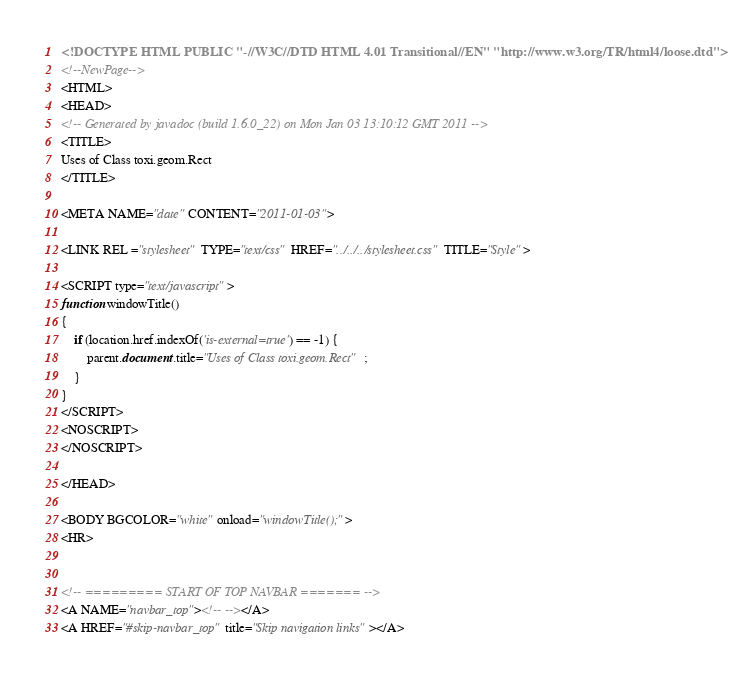<code> <loc_0><loc_0><loc_500><loc_500><_HTML_><!DOCTYPE HTML PUBLIC "-//W3C//DTD HTML 4.01 Transitional//EN" "http://www.w3.org/TR/html4/loose.dtd">
<!--NewPage-->
<HTML>
<HEAD>
<!-- Generated by javadoc (build 1.6.0_22) on Mon Jan 03 13:10:12 GMT 2011 -->
<TITLE>
Uses of Class toxi.geom.Rect
</TITLE>

<META NAME="date" CONTENT="2011-01-03">

<LINK REL ="stylesheet" TYPE="text/css" HREF="../../../stylesheet.css" TITLE="Style">

<SCRIPT type="text/javascript">
function windowTitle()
{
    if (location.href.indexOf('is-external=true') == -1) {
        parent.document.title="Uses of Class toxi.geom.Rect";
    }
}
</SCRIPT>
<NOSCRIPT>
</NOSCRIPT>

</HEAD>

<BODY BGCOLOR="white" onload="windowTitle();">
<HR>


<!-- ========= START OF TOP NAVBAR ======= -->
<A NAME="navbar_top"><!-- --></A>
<A HREF="#skip-navbar_top" title="Skip navigation links"></A></code> 